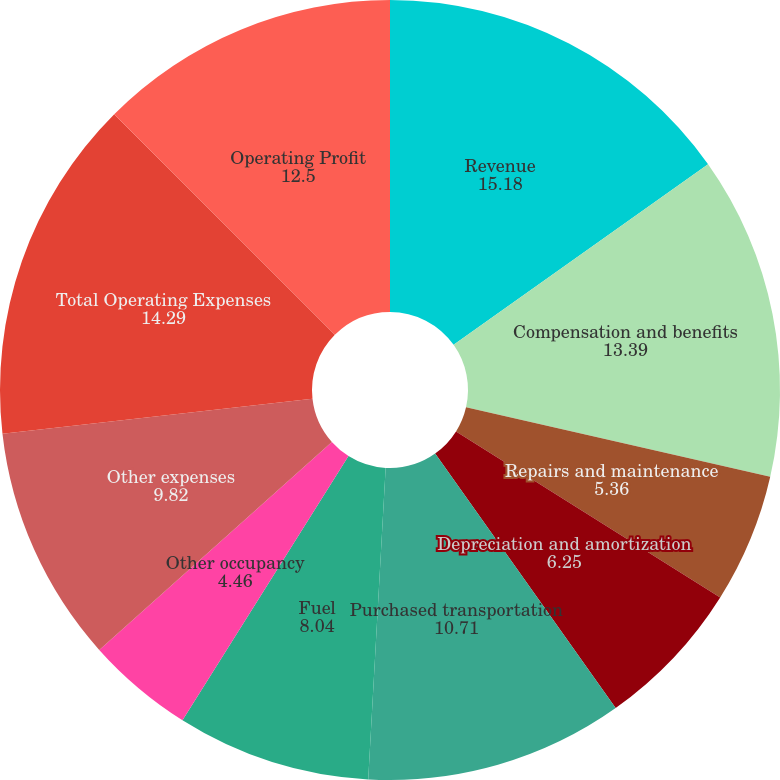Convert chart. <chart><loc_0><loc_0><loc_500><loc_500><pie_chart><fcel>Revenue<fcel>Compensation and benefits<fcel>Repairs and maintenance<fcel>Depreciation and amortization<fcel>Purchased transportation<fcel>Fuel<fcel>Other occupancy<fcel>Other expenses<fcel>Total Operating Expenses<fcel>Operating Profit<nl><fcel>15.18%<fcel>13.39%<fcel>5.36%<fcel>6.25%<fcel>10.71%<fcel>8.04%<fcel>4.46%<fcel>9.82%<fcel>14.29%<fcel>12.5%<nl></chart> 